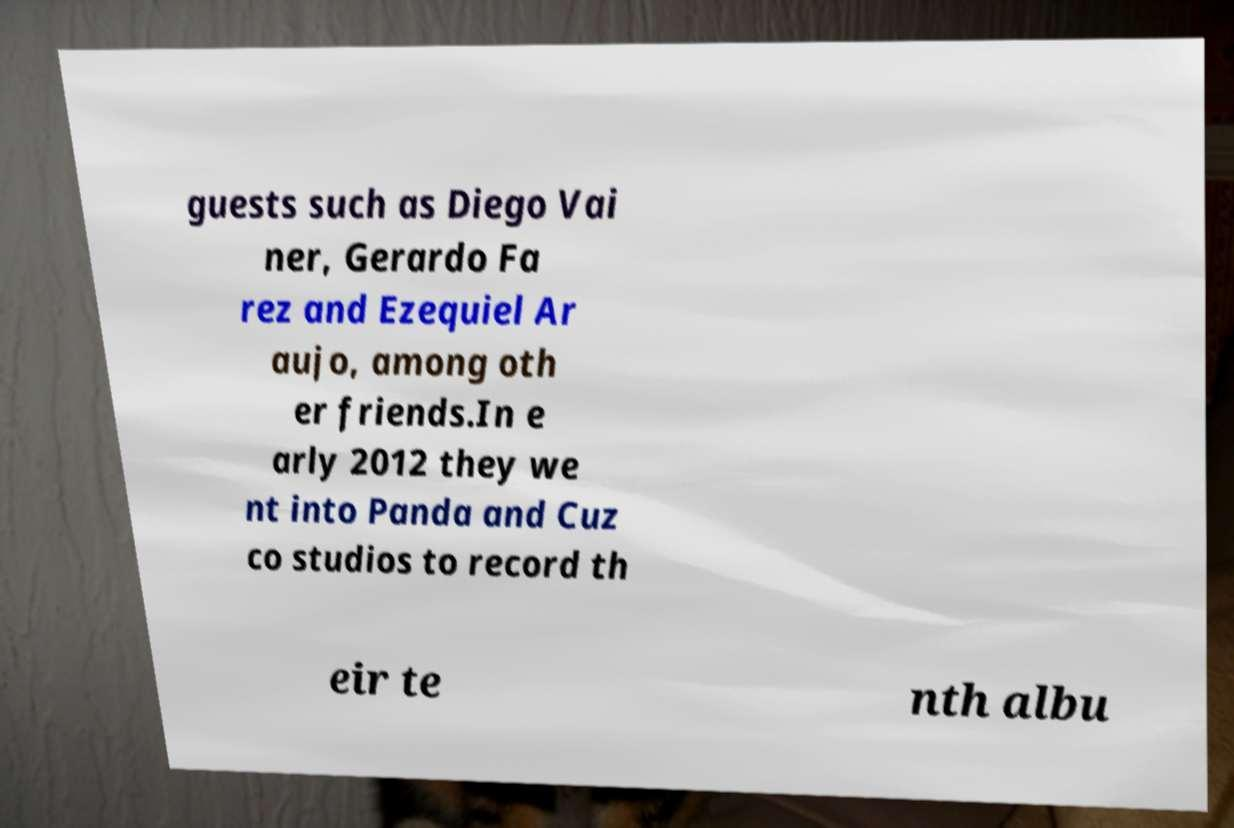What messages or text are displayed in this image? I need them in a readable, typed format. guests such as Diego Vai ner, Gerardo Fa rez and Ezequiel Ar aujo, among oth er friends.In e arly 2012 they we nt into Panda and Cuz co studios to record th eir te nth albu 